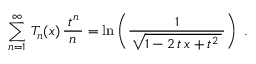<formula> <loc_0><loc_0><loc_500><loc_500>\sum _ { n = 1 } ^ { \infty } \, T _ { n } ( x ) \, { \frac { \, t ^ { n } \, } { n } } = \ln \left ( { \frac { 1 } { \, { \sqrt { 1 - 2 \, t \, x + t ^ { 2 } \, } } \, } } \right ) .</formula> 